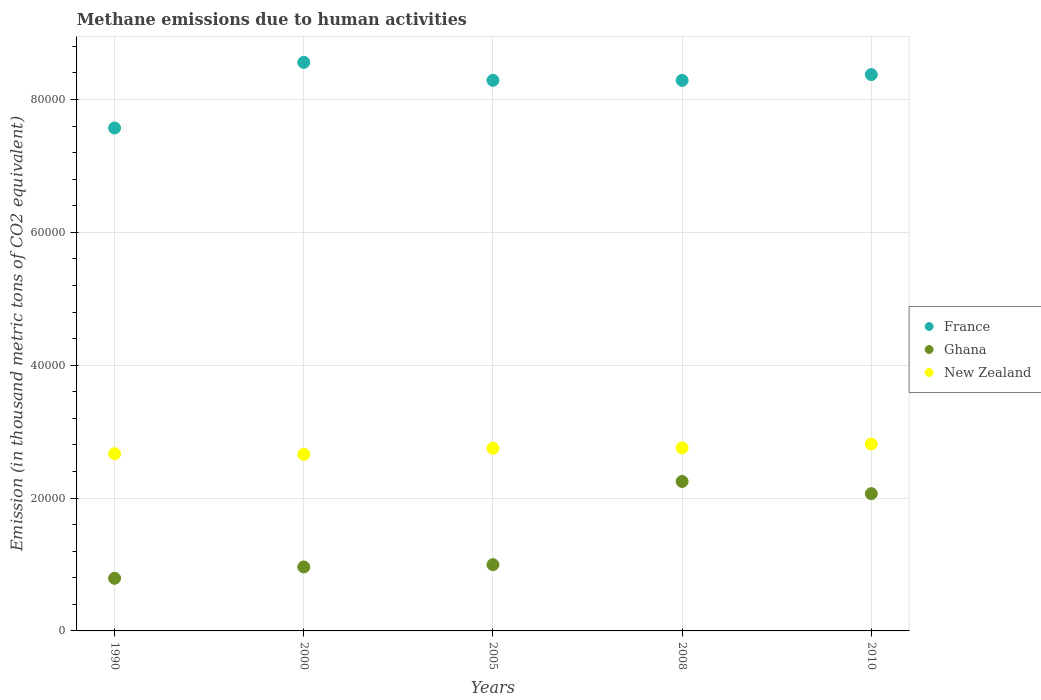Is the number of dotlines equal to the number of legend labels?
Offer a terse response. Yes. What is the amount of methane emitted in France in 2008?
Your response must be concise. 8.29e+04. Across all years, what is the maximum amount of methane emitted in New Zealand?
Ensure brevity in your answer.  2.81e+04. Across all years, what is the minimum amount of methane emitted in Ghana?
Your response must be concise. 7924.7. In which year was the amount of methane emitted in Ghana minimum?
Offer a very short reply. 1990. What is the total amount of methane emitted in New Zealand in the graph?
Provide a succinct answer. 1.36e+05. What is the difference between the amount of methane emitted in New Zealand in 2005 and that in 2008?
Provide a short and direct response. -61.5. What is the difference between the amount of methane emitted in France in 1990 and the amount of methane emitted in New Zealand in 2000?
Keep it short and to the point. 4.91e+04. What is the average amount of methane emitted in Ghana per year?
Provide a short and direct response. 1.41e+04. In the year 2008, what is the difference between the amount of methane emitted in New Zealand and amount of methane emitted in France?
Provide a short and direct response. -5.53e+04. What is the ratio of the amount of methane emitted in New Zealand in 1990 to that in 2008?
Provide a succinct answer. 0.97. What is the difference between the highest and the second highest amount of methane emitted in Ghana?
Keep it short and to the point. 1833. What is the difference between the highest and the lowest amount of methane emitted in New Zealand?
Offer a terse response. 1563.1. In how many years, is the amount of methane emitted in France greater than the average amount of methane emitted in France taken over all years?
Give a very brief answer. 4. Is the sum of the amount of methane emitted in France in 2000 and 2008 greater than the maximum amount of methane emitted in New Zealand across all years?
Offer a terse response. Yes. Is the amount of methane emitted in France strictly less than the amount of methane emitted in Ghana over the years?
Offer a terse response. No. How many years are there in the graph?
Your answer should be very brief. 5. What is the difference between two consecutive major ticks on the Y-axis?
Offer a very short reply. 2.00e+04. Does the graph contain grids?
Offer a terse response. Yes. Where does the legend appear in the graph?
Your answer should be very brief. Center right. What is the title of the graph?
Keep it short and to the point. Methane emissions due to human activities. What is the label or title of the X-axis?
Give a very brief answer. Years. What is the label or title of the Y-axis?
Ensure brevity in your answer.  Emission (in thousand metric tons of CO2 equivalent). What is the Emission (in thousand metric tons of CO2 equivalent) of France in 1990?
Keep it short and to the point. 7.57e+04. What is the Emission (in thousand metric tons of CO2 equivalent) in Ghana in 1990?
Offer a terse response. 7924.7. What is the Emission (in thousand metric tons of CO2 equivalent) in New Zealand in 1990?
Provide a short and direct response. 2.67e+04. What is the Emission (in thousand metric tons of CO2 equivalent) in France in 2000?
Provide a short and direct response. 8.56e+04. What is the Emission (in thousand metric tons of CO2 equivalent) of Ghana in 2000?
Offer a terse response. 9627.9. What is the Emission (in thousand metric tons of CO2 equivalent) in New Zealand in 2000?
Your answer should be compact. 2.66e+04. What is the Emission (in thousand metric tons of CO2 equivalent) in France in 2005?
Your answer should be very brief. 8.29e+04. What is the Emission (in thousand metric tons of CO2 equivalent) of Ghana in 2005?
Keep it short and to the point. 9975.3. What is the Emission (in thousand metric tons of CO2 equivalent) in New Zealand in 2005?
Your answer should be compact. 2.75e+04. What is the Emission (in thousand metric tons of CO2 equivalent) in France in 2008?
Give a very brief answer. 8.29e+04. What is the Emission (in thousand metric tons of CO2 equivalent) in Ghana in 2008?
Your answer should be compact. 2.25e+04. What is the Emission (in thousand metric tons of CO2 equivalent) in New Zealand in 2008?
Your answer should be compact. 2.76e+04. What is the Emission (in thousand metric tons of CO2 equivalent) of France in 2010?
Your answer should be very brief. 8.38e+04. What is the Emission (in thousand metric tons of CO2 equivalent) of Ghana in 2010?
Your answer should be compact. 2.07e+04. What is the Emission (in thousand metric tons of CO2 equivalent) in New Zealand in 2010?
Your answer should be very brief. 2.81e+04. Across all years, what is the maximum Emission (in thousand metric tons of CO2 equivalent) of France?
Offer a terse response. 8.56e+04. Across all years, what is the maximum Emission (in thousand metric tons of CO2 equivalent) of Ghana?
Offer a very short reply. 2.25e+04. Across all years, what is the maximum Emission (in thousand metric tons of CO2 equivalent) of New Zealand?
Your answer should be compact. 2.81e+04. Across all years, what is the minimum Emission (in thousand metric tons of CO2 equivalent) in France?
Offer a very short reply. 7.57e+04. Across all years, what is the minimum Emission (in thousand metric tons of CO2 equivalent) of Ghana?
Make the answer very short. 7924.7. Across all years, what is the minimum Emission (in thousand metric tons of CO2 equivalent) of New Zealand?
Give a very brief answer. 2.66e+04. What is the total Emission (in thousand metric tons of CO2 equivalent) of France in the graph?
Provide a short and direct response. 4.11e+05. What is the total Emission (in thousand metric tons of CO2 equivalent) in Ghana in the graph?
Provide a short and direct response. 7.07e+04. What is the total Emission (in thousand metric tons of CO2 equivalent) in New Zealand in the graph?
Offer a terse response. 1.36e+05. What is the difference between the Emission (in thousand metric tons of CO2 equivalent) in France in 1990 and that in 2000?
Provide a short and direct response. -9878.9. What is the difference between the Emission (in thousand metric tons of CO2 equivalent) of Ghana in 1990 and that in 2000?
Make the answer very short. -1703.2. What is the difference between the Emission (in thousand metric tons of CO2 equivalent) in New Zealand in 1990 and that in 2000?
Ensure brevity in your answer.  110.6. What is the difference between the Emission (in thousand metric tons of CO2 equivalent) of France in 1990 and that in 2005?
Provide a short and direct response. -7175.9. What is the difference between the Emission (in thousand metric tons of CO2 equivalent) in Ghana in 1990 and that in 2005?
Give a very brief answer. -2050.6. What is the difference between the Emission (in thousand metric tons of CO2 equivalent) of New Zealand in 1990 and that in 2005?
Your answer should be compact. -824. What is the difference between the Emission (in thousand metric tons of CO2 equivalent) in France in 1990 and that in 2008?
Your answer should be very brief. -7168.6. What is the difference between the Emission (in thousand metric tons of CO2 equivalent) of Ghana in 1990 and that in 2008?
Provide a short and direct response. -1.46e+04. What is the difference between the Emission (in thousand metric tons of CO2 equivalent) of New Zealand in 1990 and that in 2008?
Provide a succinct answer. -885.5. What is the difference between the Emission (in thousand metric tons of CO2 equivalent) in France in 1990 and that in 2010?
Your response must be concise. -8043.7. What is the difference between the Emission (in thousand metric tons of CO2 equivalent) in Ghana in 1990 and that in 2010?
Make the answer very short. -1.27e+04. What is the difference between the Emission (in thousand metric tons of CO2 equivalent) in New Zealand in 1990 and that in 2010?
Keep it short and to the point. -1452.5. What is the difference between the Emission (in thousand metric tons of CO2 equivalent) in France in 2000 and that in 2005?
Provide a short and direct response. 2703. What is the difference between the Emission (in thousand metric tons of CO2 equivalent) of Ghana in 2000 and that in 2005?
Ensure brevity in your answer.  -347.4. What is the difference between the Emission (in thousand metric tons of CO2 equivalent) of New Zealand in 2000 and that in 2005?
Ensure brevity in your answer.  -934.6. What is the difference between the Emission (in thousand metric tons of CO2 equivalent) of France in 2000 and that in 2008?
Your response must be concise. 2710.3. What is the difference between the Emission (in thousand metric tons of CO2 equivalent) of Ghana in 2000 and that in 2008?
Offer a terse response. -1.29e+04. What is the difference between the Emission (in thousand metric tons of CO2 equivalent) of New Zealand in 2000 and that in 2008?
Your response must be concise. -996.1. What is the difference between the Emission (in thousand metric tons of CO2 equivalent) of France in 2000 and that in 2010?
Your answer should be compact. 1835.2. What is the difference between the Emission (in thousand metric tons of CO2 equivalent) in Ghana in 2000 and that in 2010?
Give a very brief answer. -1.10e+04. What is the difference between the Emission (in thousand metric tons of CO2 equivalent) of New Zealand in 2000 and that in 2010?
Provide a short and direct response. -1563.1. What is the difference between the Emission (in thousand metric tons of CO2 equivalent) in Ghana in 2005 and that in 2008?
Offer a terse response. -1.25e+04. What is the difference between the Emission (in thousand metric tons of CO2 equivalent) of New Zealand in 2005 and that in 2008?
Keep it short and to the point. -61.5. What is the difference between the Emission (in thousand metric tons of CO2 equivalent) of France in 2005 and that in 2010?
Ensure brevity in your answer.  -867.8. What is the difference between the Emission (in thousand metric tons of CO2 equivalent) in Ghana in 2005 and that in 2010?
Your answer should be compact. -1.07e+04. What is the difference between the Emission (in thousand metric tons of CO2 equivalent) of New Zealand in 2005 and that in 2010?
Keep it short and to the point. -628.5. What is the difference between the Emission (in thousand metric tons of CO2 equivalent) in France in 2008 and that in 2010?
Provide a short and direct response. -875.1. What is the difference between the Emission (in thousand metric tons of CO2 equivalent) in Ghana in 2008 and that in 2010?
Offer a very short reply. 1833. What is the difference between the Emission (in thousand metric tons of CO2 equivalent) in New Zealand in 2008 and that in 2010?
Provide a succinct answer. -567. What is the difference between the Emission (in thousand metric tons of CO2 equivalent) of France in 1990 and the Emission (in thousand metric tons of CO2 equivalent) of Ghana in 2000?
Your answer should be very brief. 6.61e+04. What is the difference between the Emission (in thousand metric tons of CO2 equivalent) of France in 1990 and the Emission (in thousand metric tons of CO2 equivalent) of New Zealand in 2000?
Provide a succinct answer. 4.91e+04. What is the difference between the Emission (in thousand metric tons of CO2 equivalent) of Ghana in 1990 and the Emission (in thousand metric tons of CO2 equivalent) of New Zealand in 2000?
Your answer should be compact. -1.86e+04. What is the difference between the Emission (in thousand metric tons of CO2 equivalent) in France in 1990 and the Emission (in thousand metric tons of CO2 equivalent) in Ghana in 2005?
Offer a terse response. 6.57e+04. What is the difference between the Emission (in thousand metric tons of CO2 equivalent) in France in 1990 and the Emission (in thousand metric tons of CO2 equivalent) in New Zealand in 2005?
Offer a very short reply. 4.82e+04. What is the difference between the Emission (in thousand metric tons of CO2 equivalent) in Ghana in 1990 and the Emission (in thousand metric tons of CO2 equivalent) in New Zealand in 2005?
Provide a succinct answer. -1.96e+04. What is the difference between the Emission (in thousand metric tons of CO2 equivalent) in France in 1990 and the Emission (in thousand metric tons of CO2 equivalent) in Ghana in 2008?
Give a very brief answer. 5.32e+04. What is the difference between the Emission (in thousand metric tons of CO2 equivalent) of France in 1990 and the Emission (in thousand metric tons of CO2 equivalent) of New Zealand in 2008?
Your response must be concise. 4.81e+04. What is the difference between the Emission (in thousand metric tons of CO2 equivalent) in Ghana in 1990 and the Emission (in thousand metric tons of CO2 equivalent) in New Zealand in 2008?
Your answer should be compact. -1.96e+04. What is the difference between the Emission (in thousand metric tons of CO2 equivalent) in France in 1990 and the Emission (in thousand metric tons of CO2 equivalent) in Ghana in 2010?
Provide a short and direct response. 5.50e+04. What is the difference between the Emission (in thousand metric tons of CO2 equivalent) of France in 1990 and the Emission (in thousand metric tons of CO2 equivalent) of New Zealand in 2010?
Keep it short and to the point. 4.76e+04. What is the difference between the Emission (in thousand metric tons of CO2 equivalent) of Ghana in 1990 and the Emission (in thousand metric tons of CO2 equivalent) of New Zealand in 2010?
Ensure brevity in your answer.  -2.02e+04. What is the difference between the Emission (in thousand metric tons of CO2 equivalent) in France in 2000 and the Emission (in thousand metric tons of CO2 equivalent) in Ghana in 2005?
Keep it short and to the point. 7.56e+04. What is the difference between the Emission (in thousand metric tons of CO2 equivalent) in France in 2000 and the Emission (in thousand metric tons of CO2 equivalent) in New Zealand in 2005?
Your response must be concise. 5.81e+04. What is the difference between the Emission (in thousand metric tons of CO2 equivalent) of Ghana in 2000 and the Emission (in thousand metric tons of CO2 equivalent) of New Zealand in 2005?
Provide a succinct answer. -1.79e+04. What is the difference between the Emission (in thousand metric tons of CO2 equivalent) in France in 2000 and the Emission (in thousand metric tons of CO2 equivalent) in Ghana in 2008?
Your answer should be compact. 6.31e+04. What is the difference between the Emission (in thousand metric tons of CO2 equivalent) in France in 2000 and the Emission (in thousand metric tons of CO2 equivalent) in New Zealand in 2008?
Make the answer very short. 5.80e+04. What is the difference between the Emission (in thousand metric tons of CO2 equivalent) of Ghana in 2000 and the Emission (in thousand metric tons of CO2 equivalent) of New Zealand in 2008?
Make the answer very short. -1.79e+04. What is the difference between the Emission (in thousand metric tons of CO2 equivalent) in France in 2000 and the Emission (in thousand metric tons of CO2 equivalent) in Ghana in 2010?
Give a very brief answer. 6.49e+04. What is the difference between the Emission (in thousand metric tons of CO2 equivalent) of France in 2000 and the Emission (in thousand metric tons of CO2 equivalent) of New Zealand in 2010?
Keep it short and to the point. 5.75e+04. What is the difference between the Emission (in thousand metric tons of CO2 equivalent) of Ghana in 2000 and the Emission (in thousand metric tons of CO2 equivalent) of New Zealand in 2010?
Give a very brief answer. -1.85e+04. What is the difference between the Emission (in thousand metric tons of CO2 equivalent) of France in 2005 and the Emission (in thousand metric tons of CO2 equivalent) of Ghana in 2008?
Offer a very short reply. 6.04e+04. What is the difference between the Emission (in thousand metric tons of CO2 equivalent) in France in 2005 and the Emission (in thousand metric tons of CO2 equivalent) in New Zealand in 2008?
Keep it short and to the point. 5.53e+04. What is the difference between the Emission (in thousand metric tons of CO2 equivalent) of Ghana in 2005 and the Emission (in thousand metric tons of CO2 equivalent) of New Zealand in 2008?
Make the answer very short. -1.76e+04. What is the difference between the Emission (in thousand metric tons of CO2 equivalent) of France in 2005 and the Emission (in thousand metric tons of CO2 equivalent) of Ghana in 2010?
Your answer should be very brief. 6.22e+04. What is the difference between the Emission (in thousand metric tons of CO2 equivalent) of France in 2005 and the Emission (in thousand metric tons of CO2 equivalent) of New Zealand in 2010?
Your answer should be compact. 5.48e+04. What is the difference between the Emission (in thousand metric tons of CO2 equivalent) in Ghana in 2005 and the Emission (in thousand metric tons of CO2 equivalent) in New Zealand in 2010?
Provide a short and direct response. -1.82e+04. What is the difference between the Emission (in thousand metric tons of CO2 equivalent) in France in 2008 and the Emission (in thousand metric tons of CO2 equivalent) in Ghana in 2010?
Give a very brief answer. 6.22e+04. What is the difference between the Emission (in thousand metric tons of CO2 equivalent) of France in 2008 and the Emission (in thousand metric tons of CO2 equivalent) of New Zealand in 2010?
Provide a short and direct response. 5.47e+04. What is the difference between the Emission (in thousand metric tons of CO2 equivalent) of Ghana in 2008 and the Emission (in thousand metric tons of CO2 equivalent) of New Zealand in 2010?
Offer a very short reply. -5635.5. What is the average Emission (in thousand metric tons of CO2 equivalent) of France per year?
Your answer should be very brief. 8.22e+04. What is the average Emission (in thousand metric tons of CO2 equivalent) of Ghana per year?
Your answer should be very brief. 1.41e+04. What is the average Emission (in thousand metric tons of CO2 equivalent) in New Zealand per year?
Your answer should be compact. 2.73e+04. In the year 1990, what is the difference between the Emission (in thousand metric tons of CO2 equivalent) of France and Emission (in thousand metric tons of CO2 equivalent) of Ghana?
Your answer should be compact. 6.78e+04. In the year 1990, what is the difference between the Emission (in thousand metric tons of CO2 equivalent) in France and Emission (in thousand metric tons of CO2 equivalent) in New Zealand?
Your answer should be compact. 4.90e+04. In the year 1990, what is the difference between the Emission (in thousand metric tons of CO2 equivalent) of Ghana and Emission (in thousand metric tons of CO2 equivalent) of New Zealand?
Your answer should be compact. -1.88e+04. In the year 2000, what is the difference between the Emission (in thousand metric tons of CO2 equivalent) in France and Emission (in thousand metric tons of CO2 equivalent) in Ghana?
Your response must be concise. 7.60e+04. In the year 2000, what is the difference between the Emission (in thousand metric tons of CO2 equivalent) of France and Emission (in thousand metric tons of CO2 equivalent) of New Zealand?
Your response must be concise. 5.90e+04. In the year 2000, what is the difference between the Emission (in thousand metric tons of CO2 equivalent) of Ghana and Emission (in thousand metric tons of CO2 equivalent) of New Zealand?
Offer a terse response. -1.69e+04. In the year 2005, what is the difference between the Emission (in thousand metric tons of CO2 equivalent) of France and Emission (in thousand metric tons of CO2 equivalent) of Ghana?
Keep it short and to the point. 7.29e+04. In the year 2005, what is the difference between the Emission (in thousand metric tons of CO2 equivalent) of France and Emission (in thousand metric tons of CO2 equivalent) of New Zealand?
Give a very brief answer. 5.54e+04. In the year 2005, what is the difference between the Emission (in thousand metric tons of CO2 equivalent) of Ghana and Emission (in thousand metric tons of CO2 equivalent) of New Zealand?
Your answer should be very brief. -1.75e+04. In the year 2008, what is the difference between the Emission (in thousand metric tons of CO2 equivalent) of France and Emission (in thousand metric tons of CO2 equivalent) of Ghana?
Ensure brevity in your answer.  6.04e+04. In the year 2008, what is the difference between the Emission (in thousand metric tons of CO2 equivalent) of France and Emission (in thousand metric tons of CO2 equivalent) of New Zealand?
Offer a terse response. 5.53e+04. In the year 2008, what is the difference between the Emission (in thousand metric tons of CO2 equivalent) of Ghana and Emission (in thousand metric tons of CO2 equivalent) of New Zealand?
Make the answer very short. -5068.5. In the year 2010, what is the difference between the Emission (in thousand metric tons of CO2 equivalent) in France and Emission (in thousand metric tons of CO2 equivalent) in Ghana?
Your answer should be compact. 6.31e+04. In the year 2010, what is the difference between the Emission (in thousand metric tons of CO2 equivalent) of France and Emission (in thousand metric tons of CO2 equivalent) of New Zealand?
Ensure brevity in your answer.  5.56e+04. In the year 2010, what is the difference between the Emission (in thousand metric tons of CO2 equivalent) of Ghana and Emission (in thousand metric tons of CO2 equivalent) of New Zealand?
Your answer should be very brief. -7468.5. What is the ratio of the Emission (in thousand metric tons of CO2 equivalent) in France in 1990 to that in 2000?
Ensure brevity in your answer.  0.88. What is the ratio of the Emission (in thousand metric tons of CO2 equivalent) in Ghana in 1990 to that in 2000?
Your answer should be compact. 0.82. What is the ratio of the Emission (in thousand metric tons of CO2 equivalent) in France in 1990 to that in 2005?
Provide a succinct answer. 0.91. What is the ratio of the Emission (in thousand metric tons of CO2 equivalent) in Ghana in 1990 to that in 2005?
Provide a succinct answer. 0.79. What is the ratio of the Emission (in thousand metric tons of CO2 equivalent) of New Zealand in 1990 to that in 2005?
Keep it short and to the point. 0.97. What is the ratio of the Emission (in thousand metric tons of CO2 equivalent) in France in 1990 to that in 2008?
Your answer should be compact. 0.91. What is the ratio of the Emission (in thousand metric tons of CO2 equivalent) of Ghana in 1990 to that in 2008?
Your answer should be compact. 0.35. What is the ratio of the Emission (in thousand metric tons of CO2 equivalent) of New Zealand in 1990 to that in 2008?
Your response must be concise. 0.97. What is the ratio of the Emission (in thousand metric tons of CO2 equivalent) in France in 1990 to that in 2010?
Your answer should be compact. 0.9. What is the ratio of the Emission (in thousand metric tons of CO2 equivalent) of Ghana in 1990 to that in 2010?
Provide a succinct answer. 0.38. What is the ratio of the Emission (in thousand metric tons of CO2 equivalent) of New Zealand in 1990 to that in 2010?
Your response must be concise. 0.95. What is the ratio of the Emission (in thousand metric tons of CO2 equivalent) of France in 2000 to that in 2005?
Provide a short and direct response. 1.03. What is the ratio of the Emission (in thousand metric tons of CO2 equivalent) in Ghana in 2000 to that in 2005?
Make the answer very short. 0.97. What is the ratio of the Emission (in thousand metric tons of CO2 equivalent) in New Zealand in 2000 to that in 2005?
Provide a short and direct response. 0.97. What is the ratio of the Emission (in thousand metric tons of CO2 equivalent) in France in 2000 to that in 2008?
Keep it short and to the point. 1.03. What is the ratio of the Emission (in thousand metric tons of CO2 equivalent) in Ghana in 2000 to that in 2008?
Make the answer very short. 0.43. What is the ratio of the Emission (in thousand metric tons of CO2 equivalent) in New Zealand in 2000 to that in 2008?
Provide a short and direct response. 0.96. What is the ratio of the Emission (in thousand metric tons of CO2 equivalent) of France in 2000 to that in 2010?
Offer a very short reply. 1.02. What is the ratio of the Emission (in thousand metric tons of CO2 equivalent) of Ghana in 2000 to that in 2010?
Offer a terse response. 0.47. What is the ratio of the Emission (in thousand metric tons of CO2 equivalent) in Ghana in 2005 to that in 2008?
Keep it short and to the point. 0.44. What is the ratio of the Emission (in thousand metric tons of CO2 equivalent) of New Zealand in 2005 to that in 2008?
Ensure brevity in your answer.  1. What is the ratio of the Emission (in thousand metric tons of CO2 equivalent) of Ghana in 2005 to that in 2010?
Offer a very short reply. 0.48. What is the ratio of the Emission (in thousand metric tons of CO2 equivalent) in New Zealand in 2005 to that in 2010?
Your answer should be very brief. 0.98. What is the ratio of the Emission (in thousand metric tons of CO2 equivalent) in France in 2008 to that in 2010?
Give a very brief answer. 0.99. What is the ratio of the Emission (in thousand metric tons of CO2 equivalent) in Ghana in 2008 to that in 2010?
Your answer should be very brief. 1.09. What is the ratio of the Emission (in thousand metric tons of CO2 equivalent) of New Zealand in 2008 to that in 2010?
Provide a succinct answer. 0.98. What is the difference between the highest and the second highest Emission (in thousand metric tons of CO2 equivalent) in France?
Offer a very short reply. 1835.2. What is the difference between the highest and the second highest Emission (in thousand metric tons of CO2 equivalent) in Ghana?
Make the answer very short. 1833. What is the difference between the highest and the second highest Emission (in thousand metric tons of CO2 equivalent) of New Zealand?
Your answer should be very brief. 567. What is the difference between the highest and the lowest Emission (in thousand metric tons of CO2 equivalent) of France?
Your answer should be very brief. 9878.9. What is the difference between the highest and the lowest Emission (in thousand metric tons of CO2 equivalent) of Ghana?
Offer a very short reply. 1.46e+04. What is the difference between the highest and the lowest Emission (in thousand metric tons of CO2 equivalent) in New Zealand?
Offer a terse response. 1563.1. 